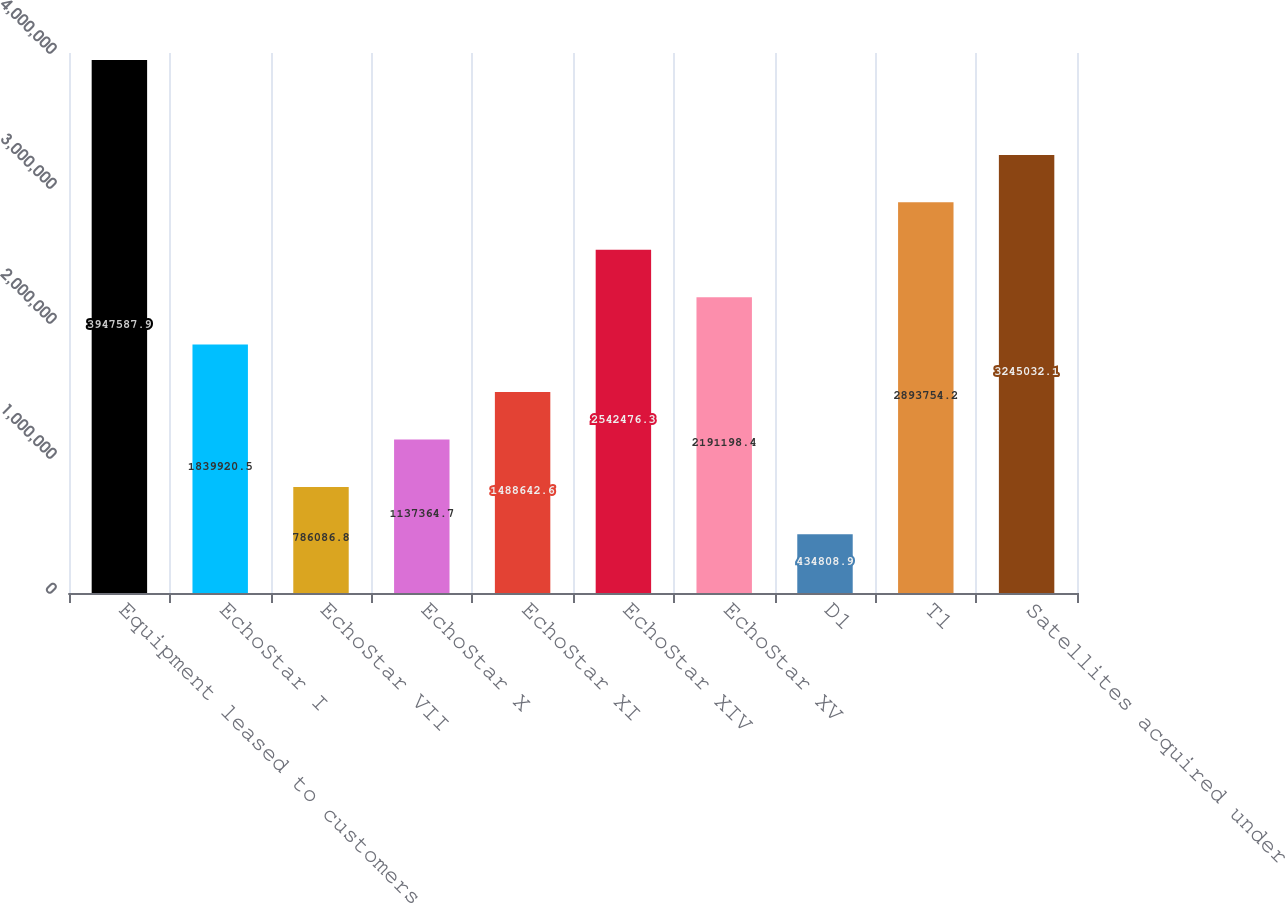Convert chart to OTSL. <chart><loc_0><loc_0><loc_500><loc_500><bar_chart><fcel>Equipment leased to customers<fcel>EchoStar I<fcel>EchoStar VII<fcel>EchoStar X<fcel>EchoStar XI<fcel>EchoStar XIV<fcel>EchoStar XV<fcel>D1<fcel>T1<fcel>Satellites acquired under<nl><fcel>3.94759e+06<fcel>1.83992e+06<fcel>786087<fcel>1.13736e+06<fcel>1.48864e+06<fcel>2.54248e+06<fcel>2.1912e+06<fcel>434809<fcel>2.89375e+06<fcel>3.24503e+06<nl></chart> 